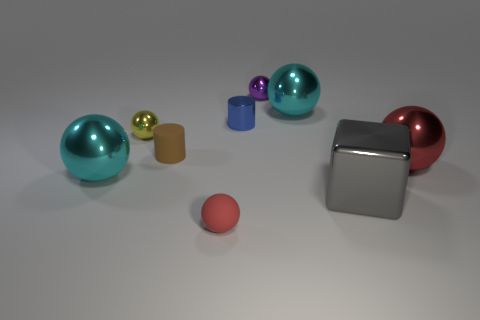There is a cyan object left of the purple metal ball; does it have the same size as the red sphere on the right side of the big gray shiny thing?
Provide a succinct answer. Yes. There is a gray shiny thing in front of the big red object on the right side of the tiny matte cylinder; what shape is it?
Offer a very short reply. Cube. Is the number of yellow things that are behind the small yellow shiny sphere the same as the number of tiny blue shiny balls?
Your answer should be compact. Yes. What is the material of the tiny thing that is in front of the big cyan metal sphere in front of the small cylinder in front of the metallic cylinder?
Provide a succinct answer. Rubber. Are there any brown cylinders of the same size as the yellow thing?
Provide a succinct answer. Yes. The tiny blue metal thing is what shape?
Your answer should be very brief. Cylinder. What number of blocks are tiny gray rubber objects or matte things?
Offer a terse response. 0. Are there the same number of red shiny things in front of the big red shiny sphere and big balls that are to the right of the red rubber ball?
Keep it short and to the point. No. There is a big cyan shiny object left of the tiny shiny object behind the blue metallic cylinder; how many gray cubes are left of it?
Your response must be concise. 0. What shape is the big thing that is the same color as the rubber ball?
Provide a short and direct response. Sphere. 